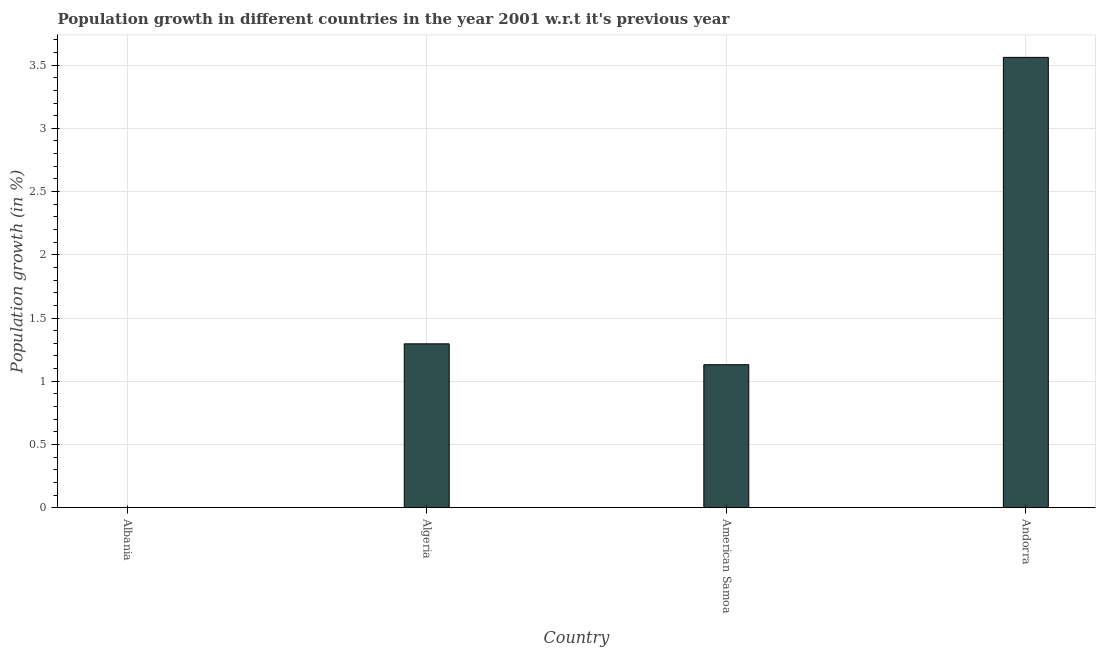Does the graph contain grids?
Offer a very short reply. Yes. What is the title of the graph?
Make the answer very short. Population growth in different countries in the year 2001 w.r.t it's previous year. What is the label or title of the X-axis?
Make the answer very short. Country. What is the label or title of the Y-axis?
Offer a terse response. Population growth (in %). What is the population growth in American Samoa?
Your response must be concise. 1.13. Across all countries, what is the maximum population growth?
Offer a very short reply. 3.56. In which country was the population growth maximum?
Provide a short and direct response. Andorra. What is the sum of the population growth?
Offer a terse response. 5.99. What is the difference between the population growth in Algeria and American Samoa?
Provide a short and direct response. 0.17. What is the average population growth per country?
Your response must be concise. 1.5. What is the median population growth?
Offer a terse response. 1.21. What is the ratio of the population growth in American Samoa to that in Andorra?
Offer a very short reply. 0.32. Is the population growth in American Samoa less than that in Andorra?
Your answer should be compact. Yes. What is the difference between the highest and the second highest population growth?
Your response must be concise. 2.27. Is the sum of the population growth in Algeria and American Samoa greater than the maximum population growth across all countries?
Provide a succinct answer. No. What is the difference between the highest and the lowest population growth?
Provide a succinct answer. 3.56. In how many countries, is the population growth greater than the average population growth taken over all countries?
Make the answer very short. 1. Are all the bars in the graph horizontal?
Keep it short and to the point. No. What is the difference between two consecutive major ticks on the Y-axis?
Keep it short and to the point. 0.5. Are the values on the major ticks of Y-axis written in scientific E-notation?
Your answer should be compact. No. What is the Population growth (in %) in Albania?
Your answer should be compact. 0. What is the Population growth (in %) of Algeria?
Your answer should be very brief. 1.3. What is the Population growth (in %) of American Samoa?
Provide a short and direct response. 1.13. What is the Population growth (in %) in Andorra?
Your response must be concise. 3.56. What is the difference between the Population growth (in %) in Algeria and American Samoa?
Offer a terse response. 0.17. What is the difference between the Population growth (in %) in Algeria and Andorra?
Your response must be concise. -2.27. What is the difference between the Population growth (in %) in American Samoa and Andorra?
Offer a terse response. -2.43. What is the ratio of the Population growth (in %) in Algeria to that in American Samoa?
Keep it short and to the point. 1.15. What is the ratio of the Population growth (in %) in Algeria to that in Andorra?
Give a very brief answer. 0.36. What is the ratio of the Population growth (in %) in American Samoa to that in Andorra?
Provide a short and direct response. 0.32. 